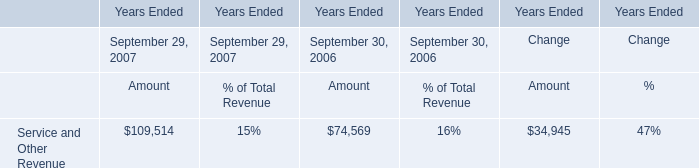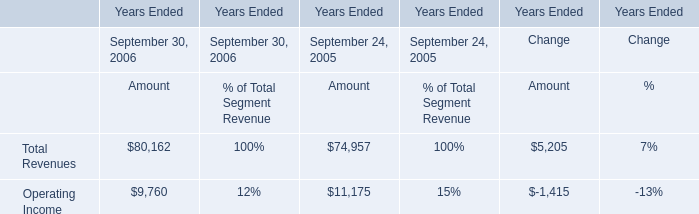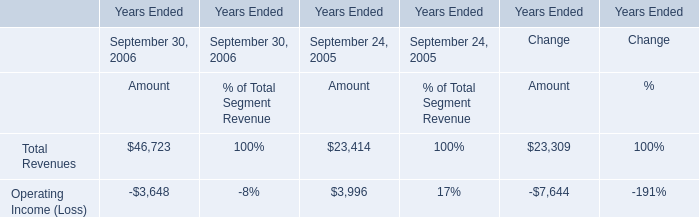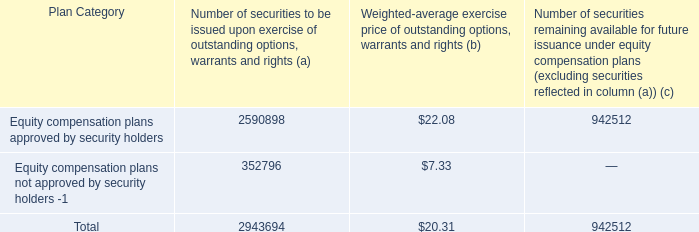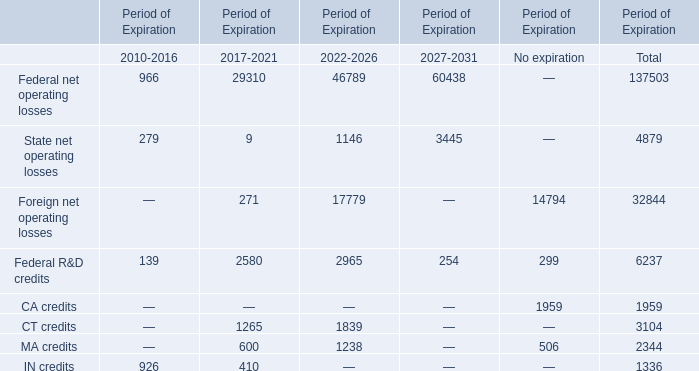What is the ratio of Operating Income of Amount in Table 1 to the Operating Income (Loss) of Amount in Table 2 in 2005? 
Computations: (11175 / 3996)
Answer: 2.79655. 